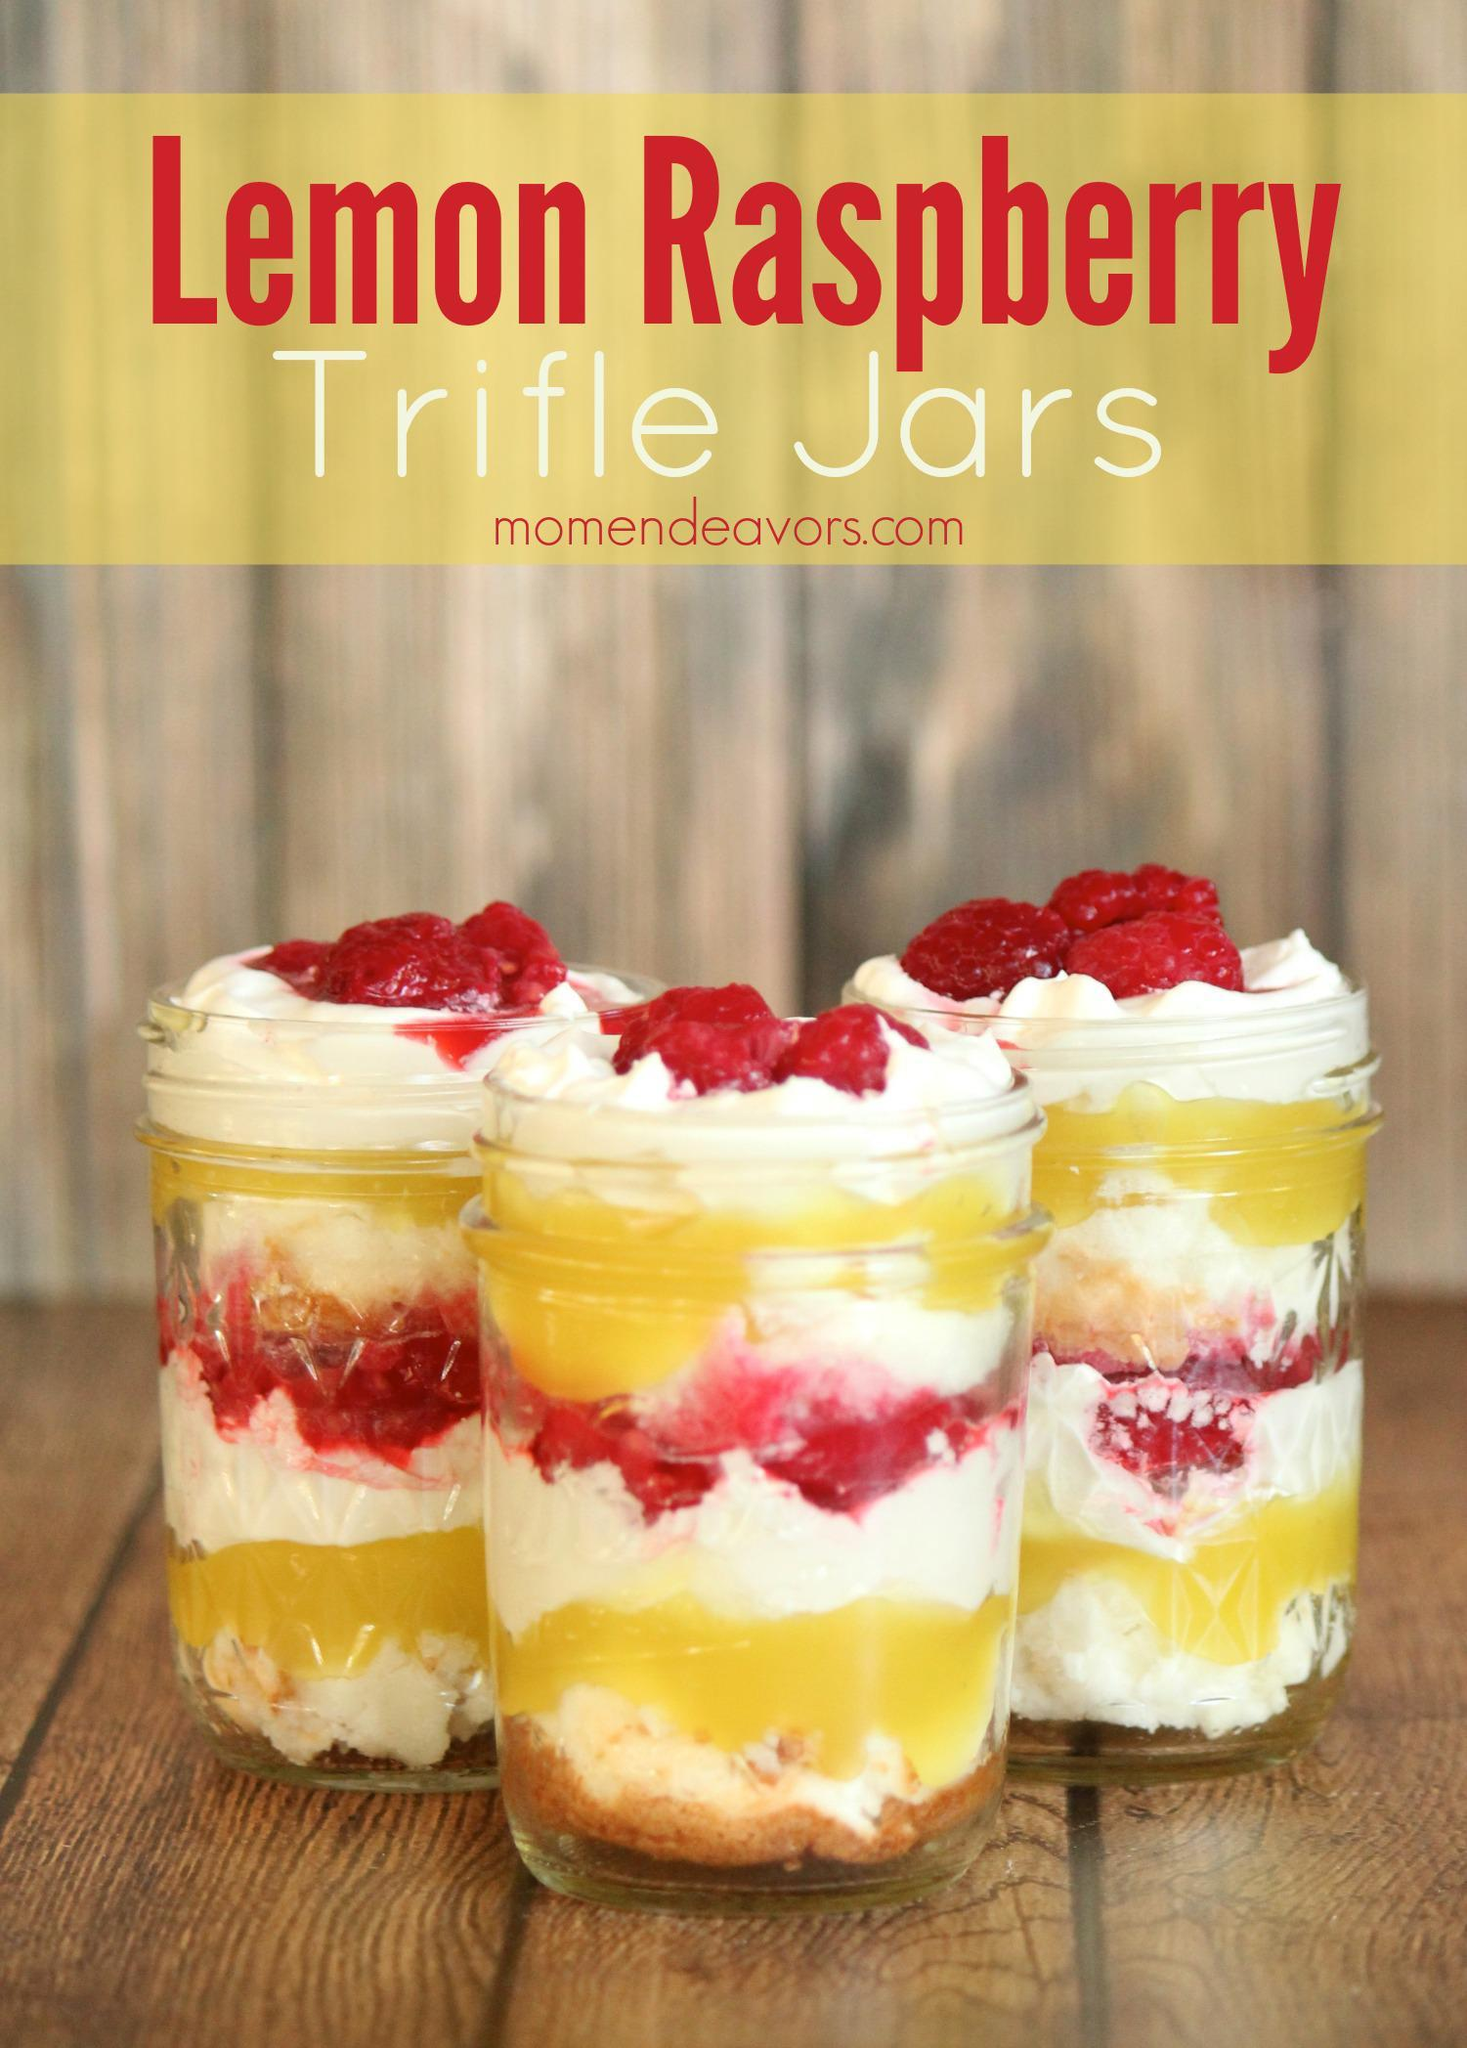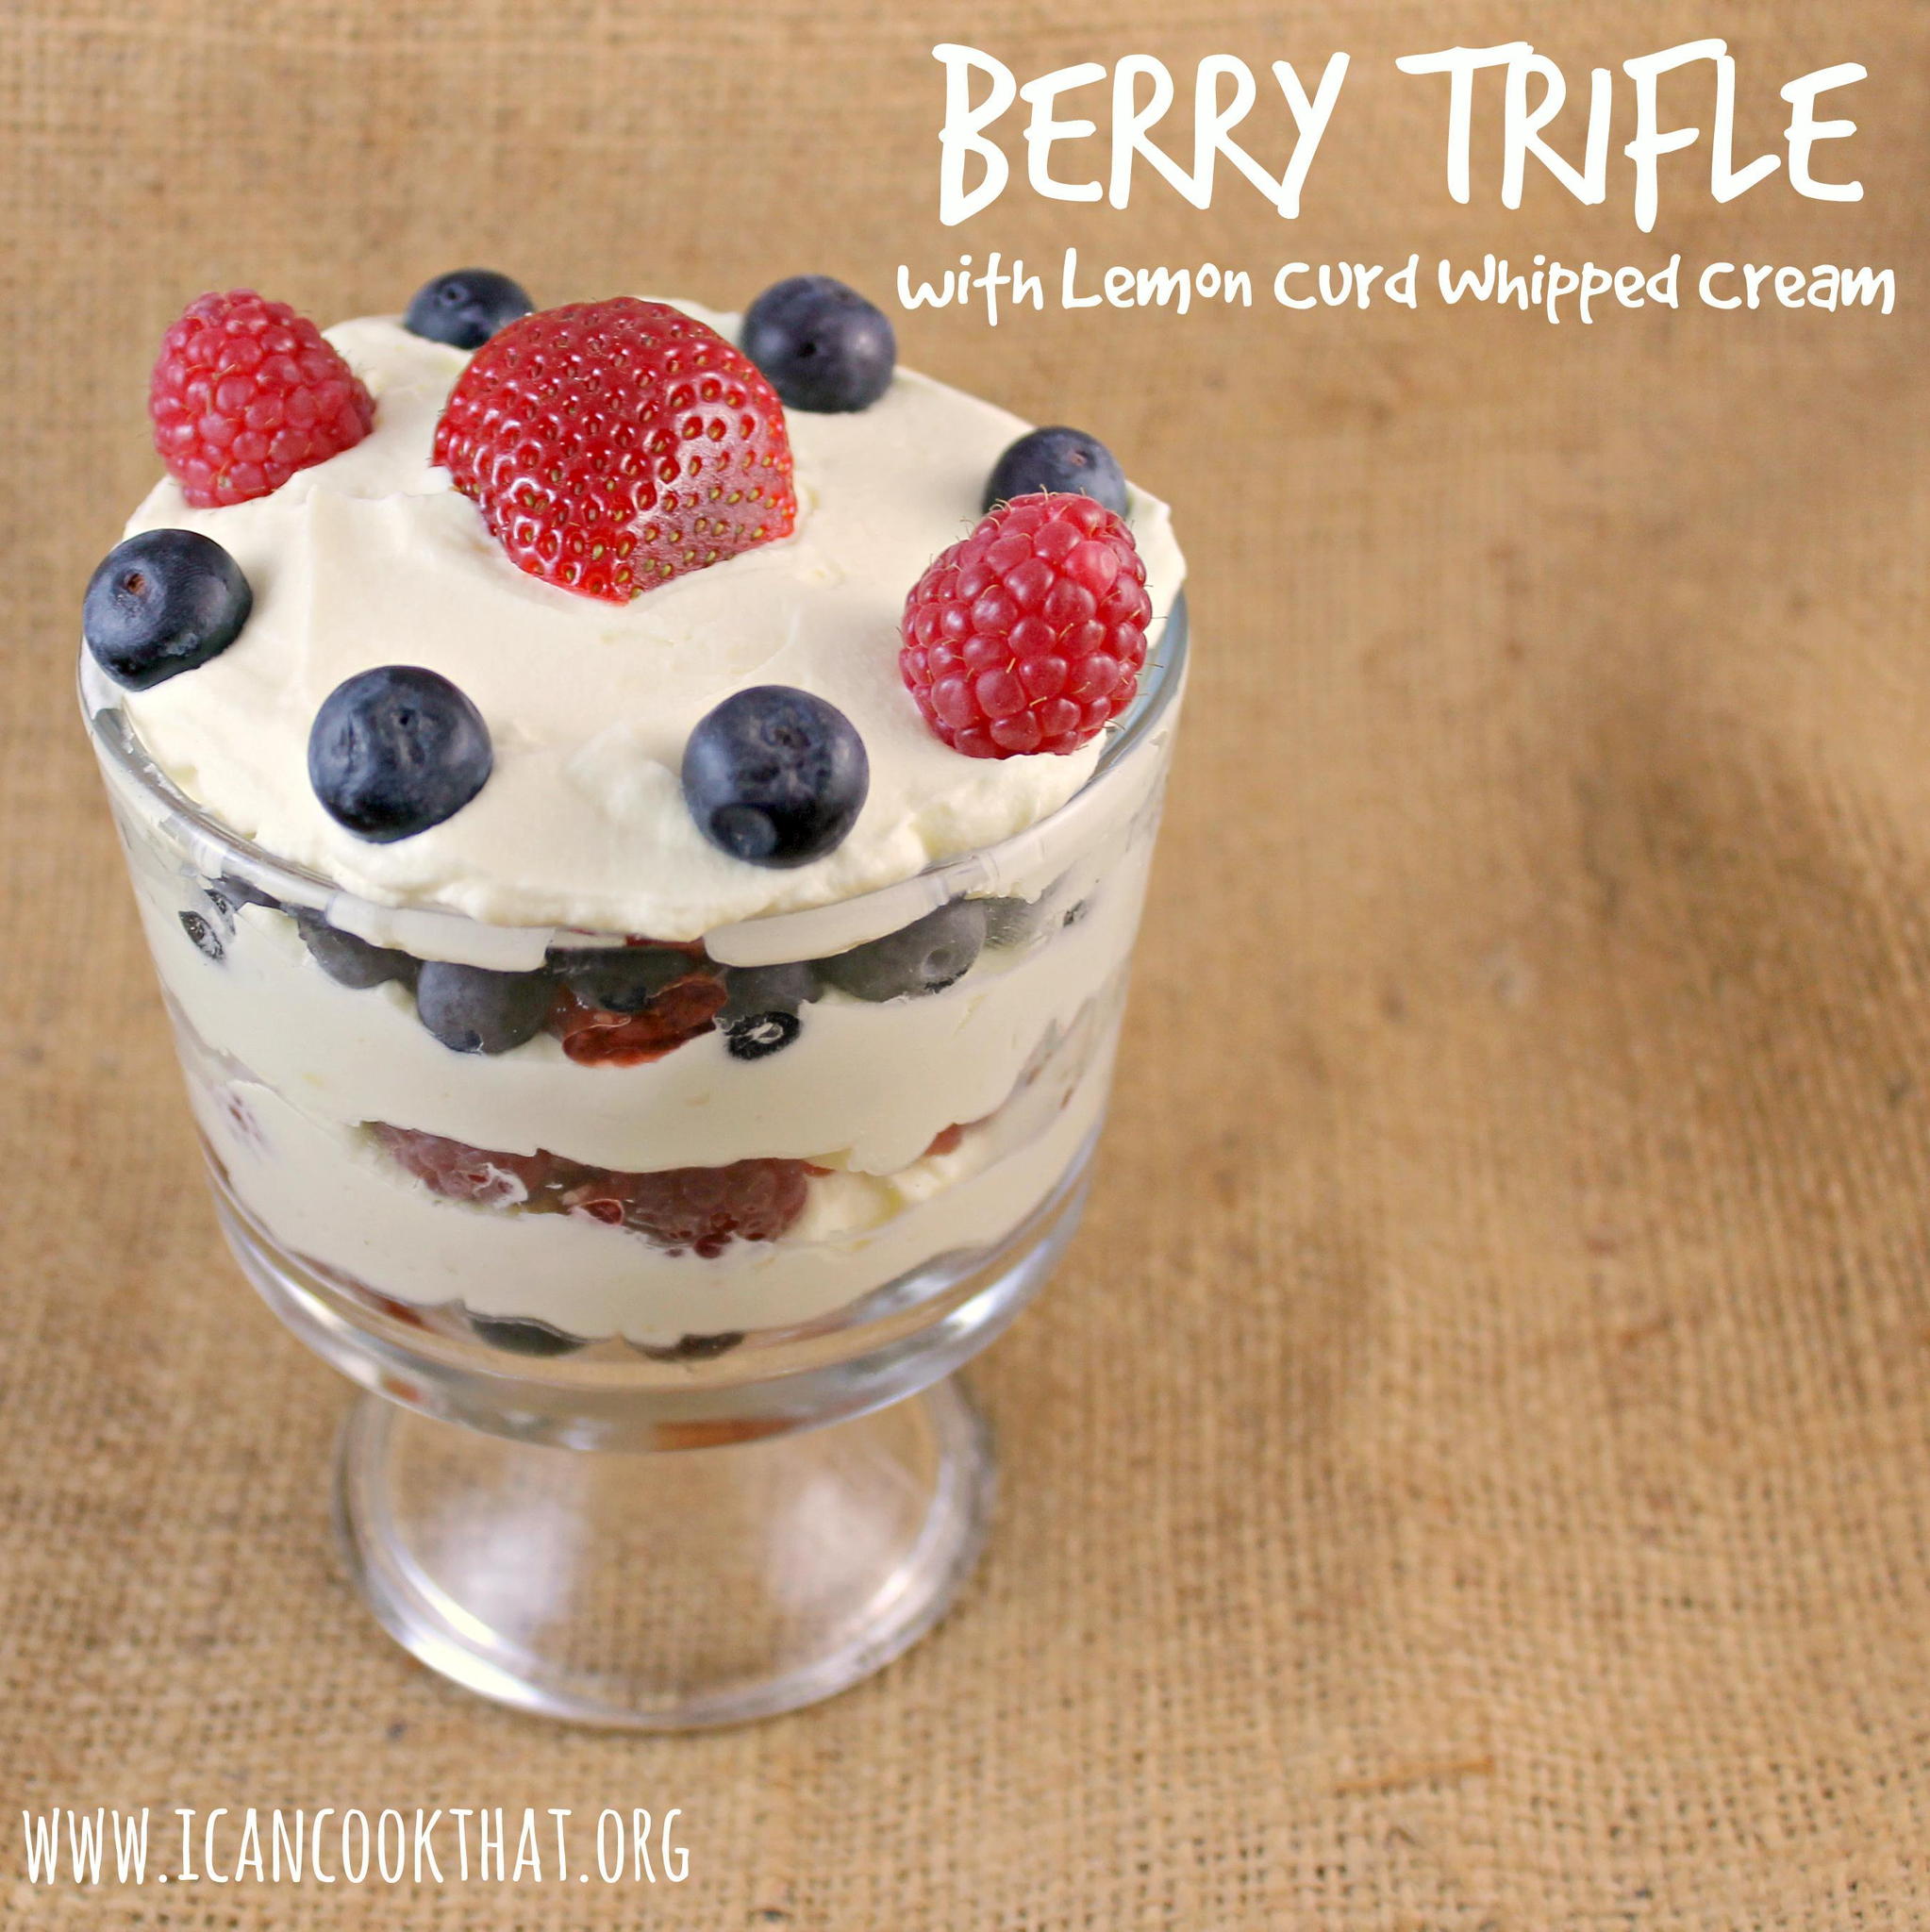The first image is the image on the left, the second image is the image on the right. Examine the images to the left and right. Is the description "There are at least four different recipes in cups." accurate? Answer yes or no. No. The first image is the image on the left, the second image is the image on the right. Evaluate the accuracy of this statement regarding the images: "there are blueberries on the top of the dessert on the right". Is it true? Answer yes or no. Yes. 